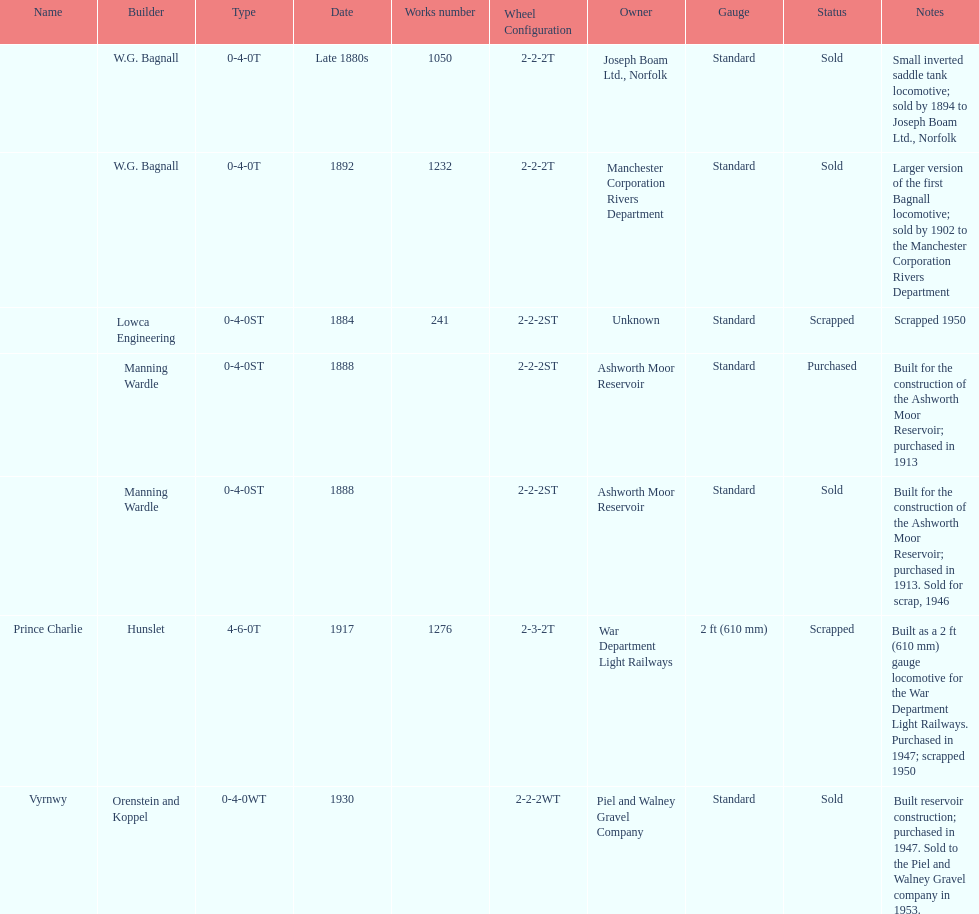Who built the larger version of the first bagnall locomotive? W.G. Bagnall. 